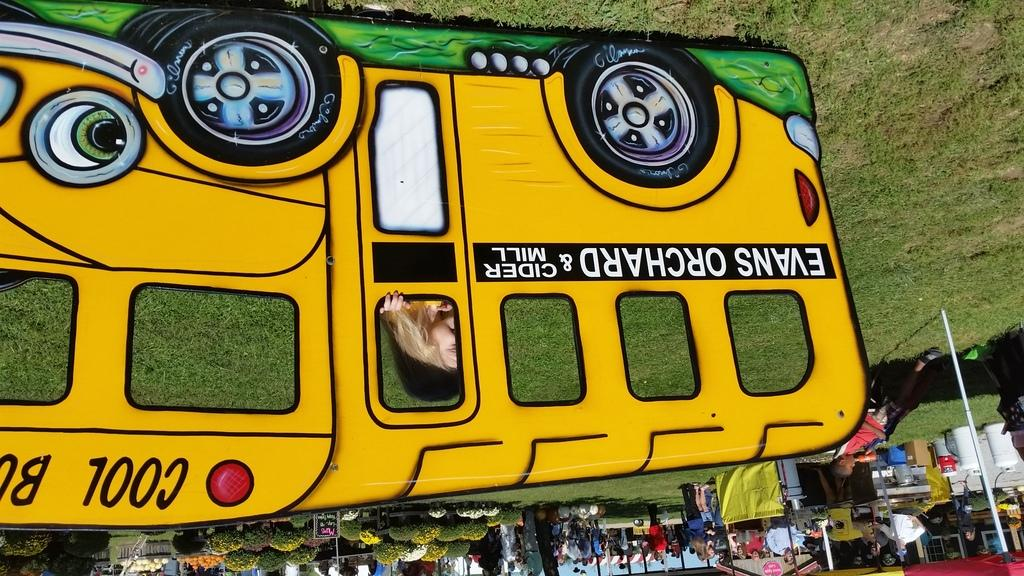What shape is the image in? The image is in the shape of a bus. Can you describe the people in the image? Unfortunately, the facts provided do not give any details about the people in the image. However, we can confirm that there are people present. What color is the crayon being used by the person in the image? There is no crayon present in the image, so we cannot determine its color. 